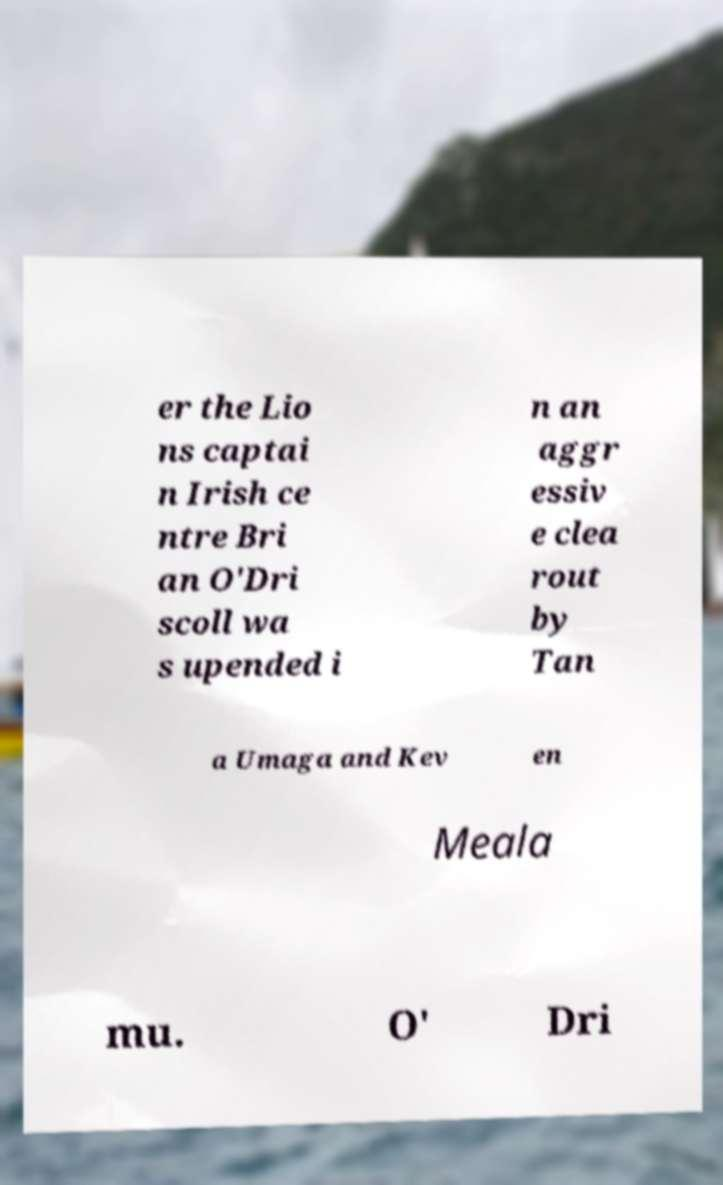There's text embedded in this image that I need extracted. Can you transcribe it verbatim? er the Lio ns captai n Irish ce ntre Bri an O'Dri scoll wa s upended i n an aggr essiv e clea rout by Tan a Umaga and Kev en Meala mu. O' Dri 